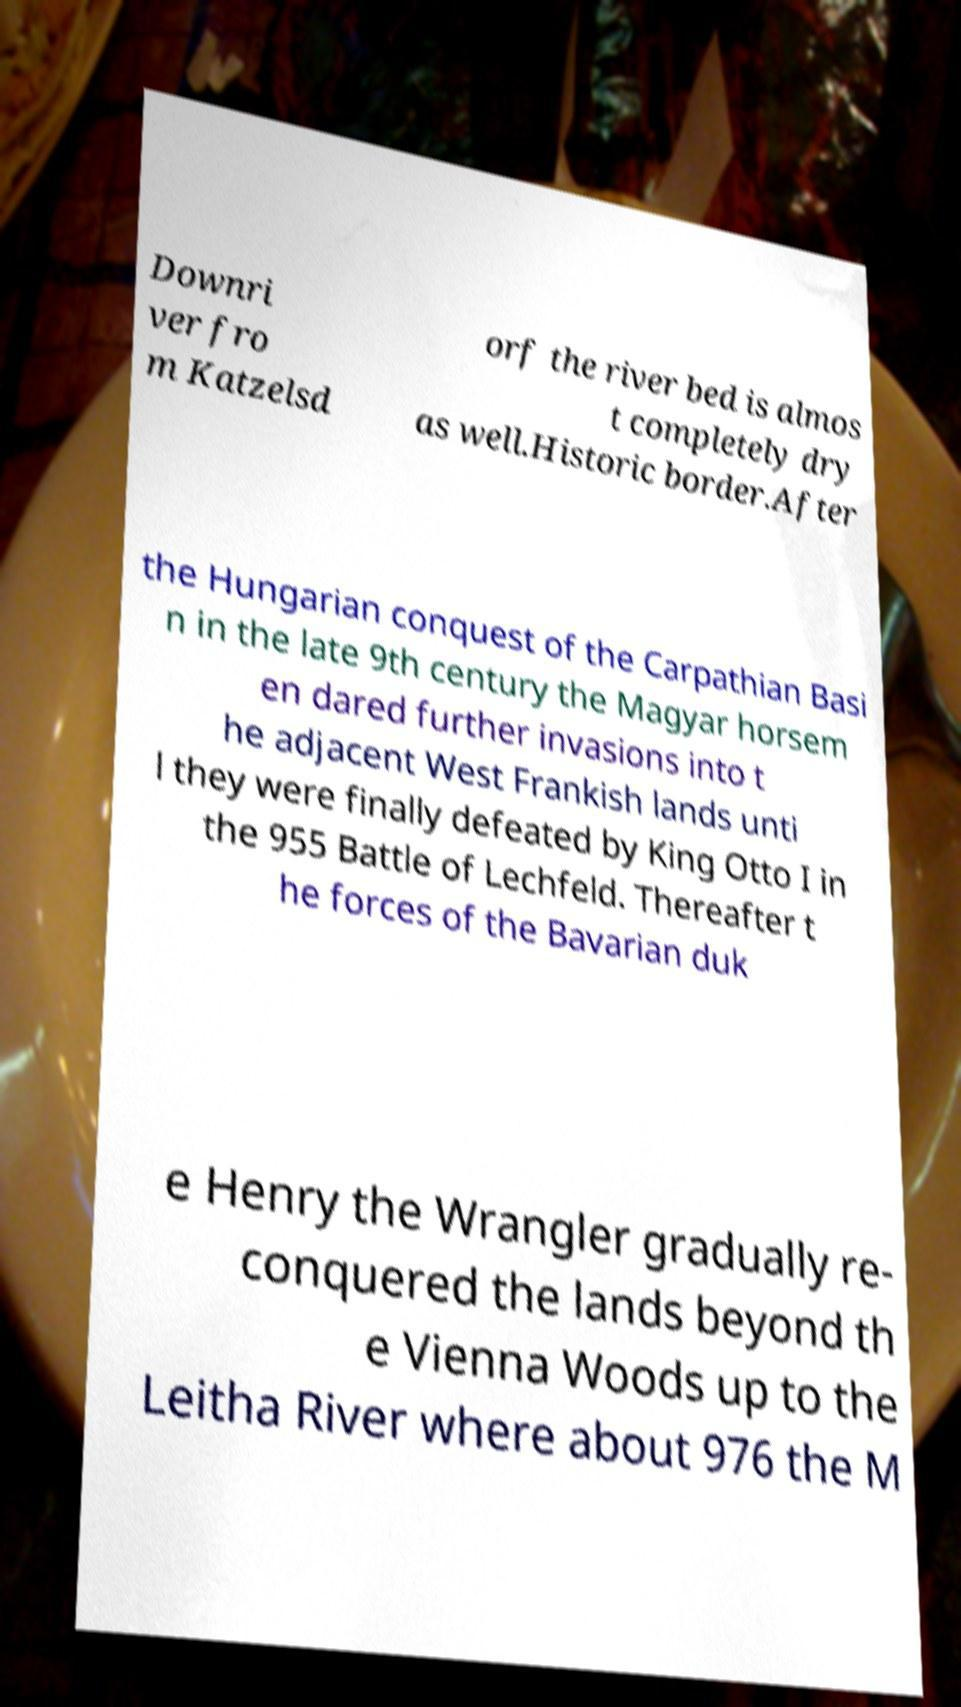I need the written content from this picture converted into text. Can you do that? Downri ver fro m Katzelsd orf the river bed is almos t completely dry as well.Historic border.After the Hungarian conquest of the Carpathian Basi n in the late 9th century the Magyar horsem en dared further invasions into t he adjacent West Frankish lands unti l they were finally defeated by King Otto I in the 955 Battle of Lechfeld. Thereafter t he forces of the Bavarian duk e Henry the Wrangler gradually re- conquered the lands beyond th e Vienna Woods up to the Leitha River where about 976 the M 